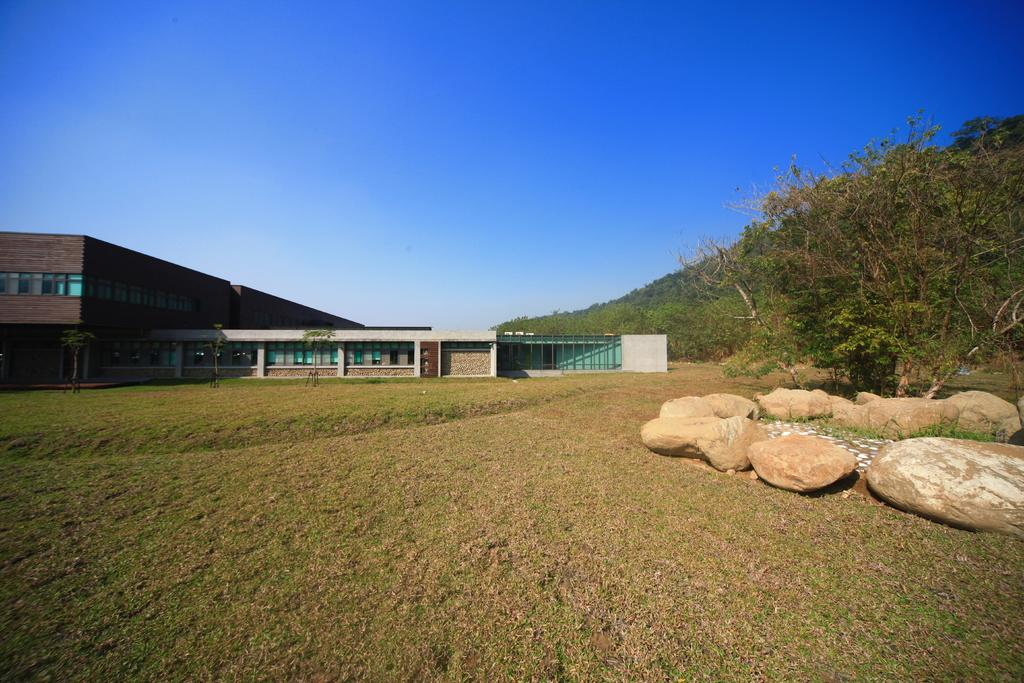What type of ground surface is visible in the image? There is grass on the ground in the image. What can be seen on the right side of the image? There are rocks on the right side of the image. What type of vegetation is present in the image? There are trees in the image. What is visible in the background of the image? There are buildings and the sky visible in the background of the image. What type of metal is used to create the cream in the image? There is no cream or metal present in the image. 